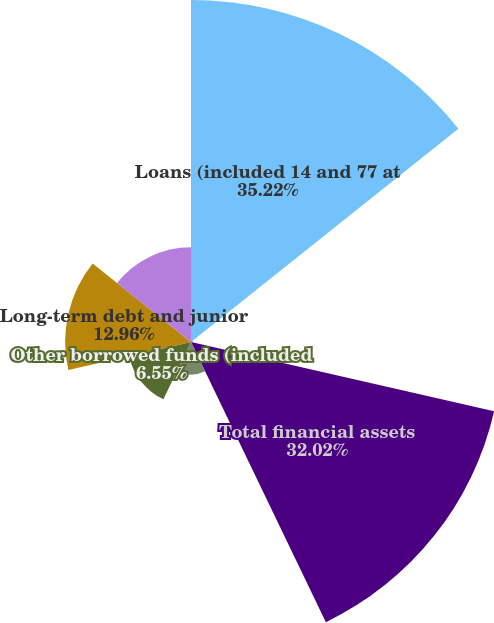<chart> <loc_0><loc_0><loc_500><loc_500><pie_chart><fcel>Loans (included 14 and 77 at<fcel>Other (included 192 and 292 at<fcel>Total financial assets<fcel>Deposits (included 45 and 56<fcel>Other borrowed funds (included<fcel>Long-term debt and junior<fcel>Total financial liabilities<nl><fcel>35.22%<fcel>0.15%<fcel>32.02%<fcel>3.35%<fcel>6.55%<fcel>12.96%<fcel>9.75%<nl></chart> 